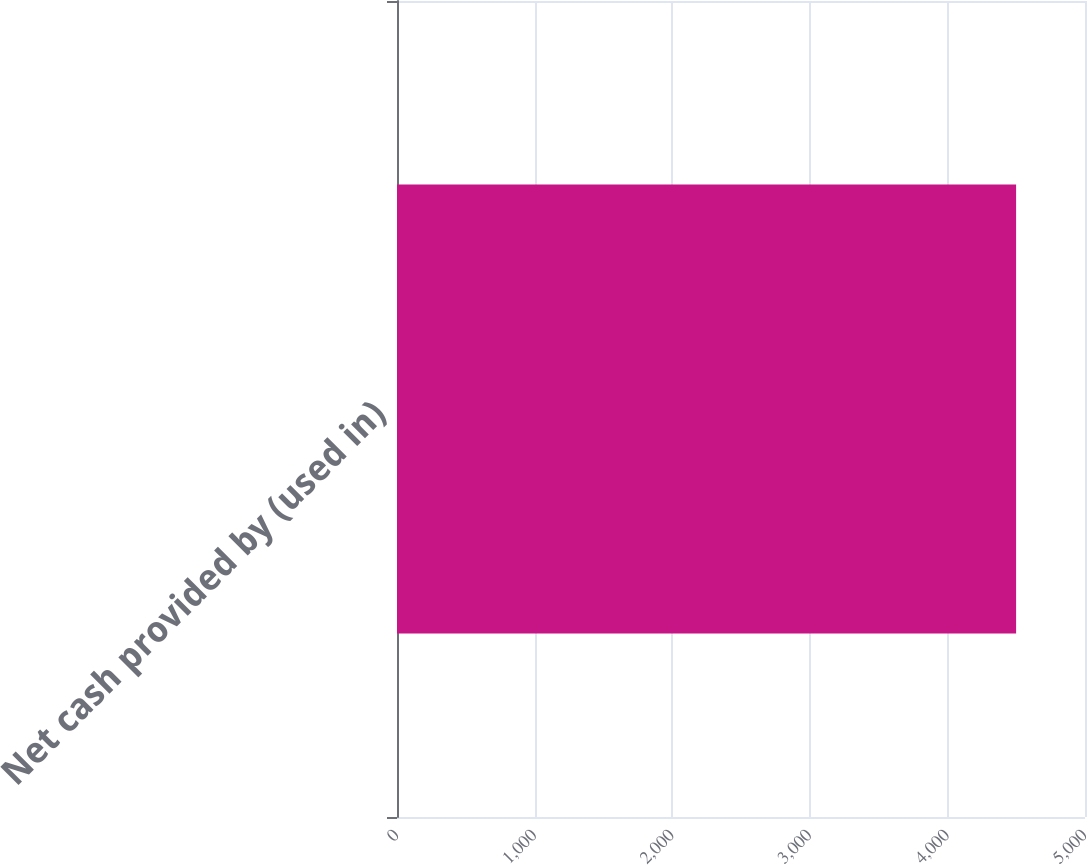Convert chart. <chart><loc_0><loc_0><loc_500><loc_500><bar_chart><fcel>Net cash provided by (used in)<nl><fcel>4499.2<nl></chart> 